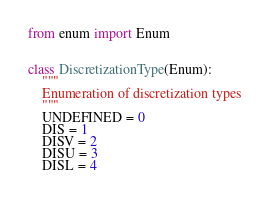<code> <loc_0><loc_0><loc_500><loc_500><_Python_>from enum import Enum


class DiscretizationType(Enum):
    """
    Enumeration of discretization types
    """
    UNDEFINED = 0
    DIS = 1
    DISV = 2
    DISU = 3
    DISL = 4
</code> 